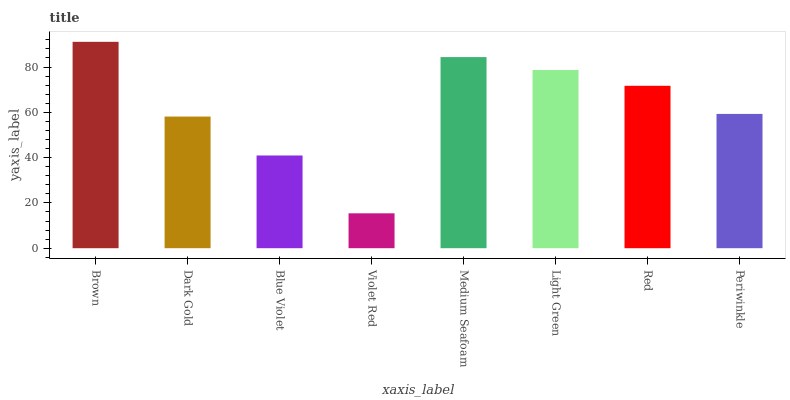Is Violet Red the minimum?
Answer yes or no. Yes. Is Brown the maximum?
Answer yes or no. Yes. Is Dark Gold the minimum?
Answer yes or no. No. Is Dark Gold the maximum?
Answer yes or no. No. Is Brown greater than Dark Gold?
Answer yes or no. Yes. Is Dark Gold less than Brown?
Answer yes or no. Yes. Is Dark Gold greater than Brown?
Answer yes or no. No. Is Brown less than Dark Gold?
Answer yes or no. No. Is Red the high median?
Answer yes or no. Yes. Is Periwinkle the low median?
Answer yes or no. Yes. Is Light Green the high median?
Answer yes or no. No. Is Medium Seafoam the low median?
Answer yes or no. No. 